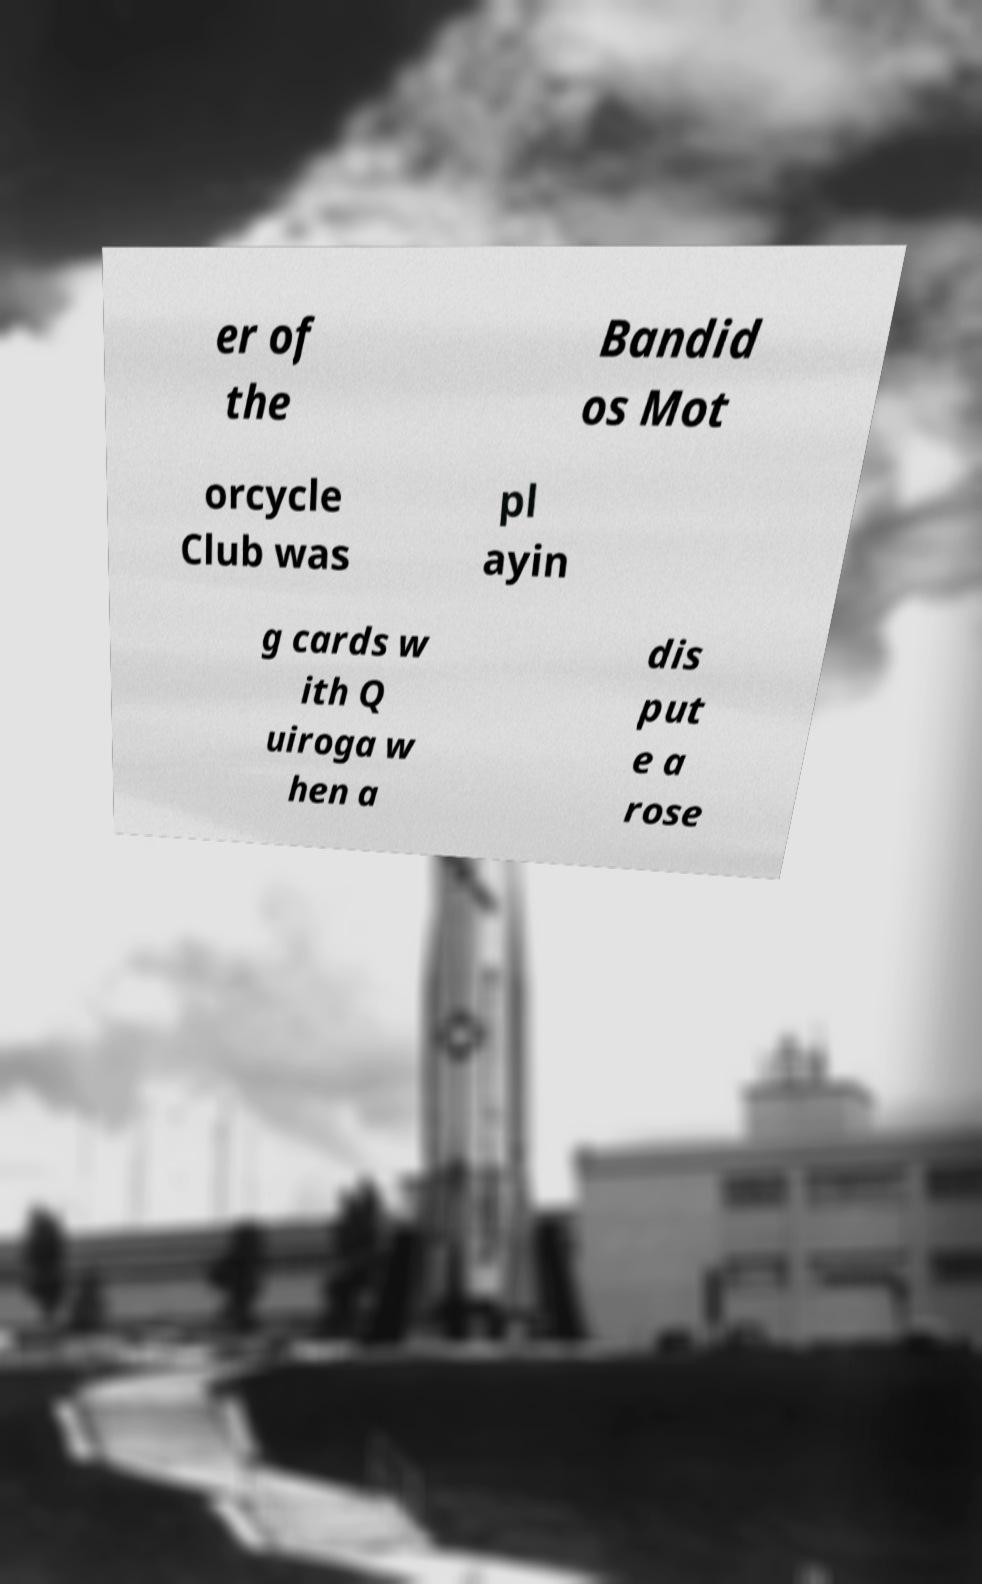Please read and relay the text visible in this image. What does it say? er of the Bandid os Mot orcycle Club was pl ayin g cards w ith Q uiroga w hen a dis put e a rose 